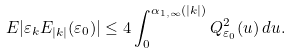<formula> <loc_0><loc_0><loc_500><loc_500>E | \varepsilon _ { k } E _ { | k | } ( \varepsilon _ { 0 } ) | & \leq 4 \int _ { 0 } ^ { \alpha _ { 1 , \infty } ( | k | ) } Q _ { \varepsilon _ { 0 } } ^ { 2 } ( u ) \, d u .</formula> 